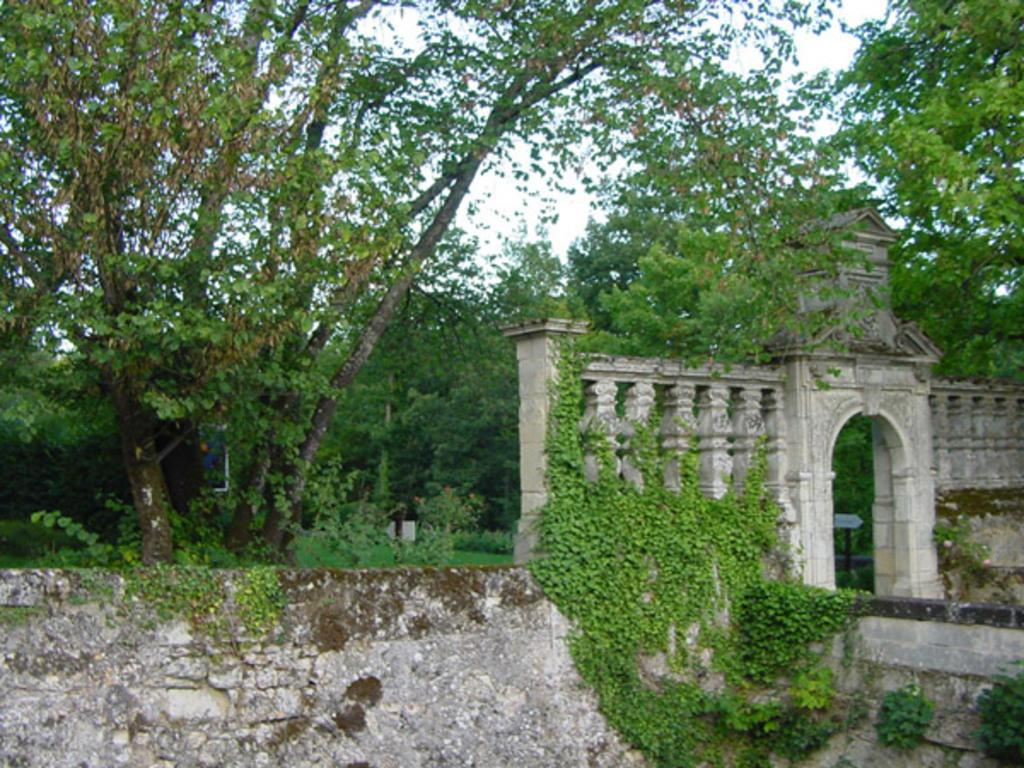What type of living organisms can be seen in the image? Plants and trees can be seen in the image. What architectural features are present in the image? There are archways in the image. What can be seen in the background of the image? The sky is visible in the background of the image. What type of industry is represented by the plants in the image? The image does not depict any specific industry; it simply features plants and trees. Can you see an umbrella being used in the image? There is no umbrella present in the image. 